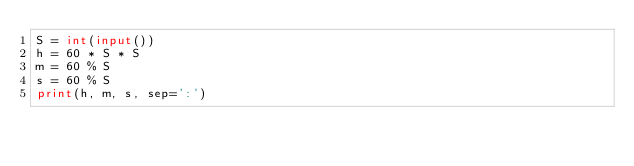<code> <loc_0><loc_0><loc_500><loc_500><_Python_>S = int(input())
h = 60 * S * S
m = 60 % S
s = 60 % S
print(h, m, s, sep=':')</code> 